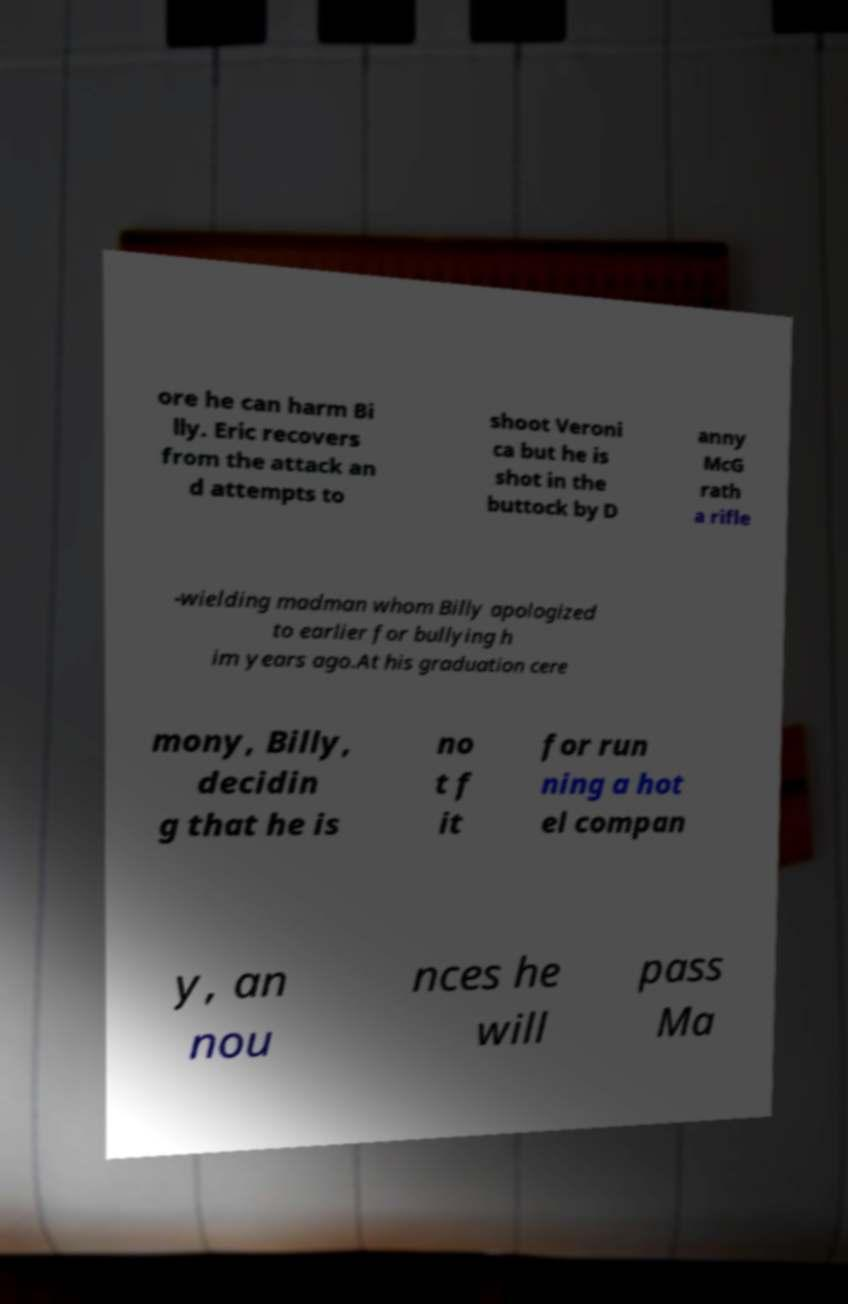Can you read and provide the text displayed in the image?This photo seems to have some interesting text. Can you extract and type it out for me? ore he can harm Bi lly. Eric recovers from the attack an d attempts to shoot Veroni ca but he is shot in the buttock by D anny McG rath a rifle -wielding madman whom Billy apologized to earlier for bullying h im years ago.At his graduation cere mony, Billy, decidin g that he is no t f it for run ning a hot el compan y, an nou nces he will pass Ma 